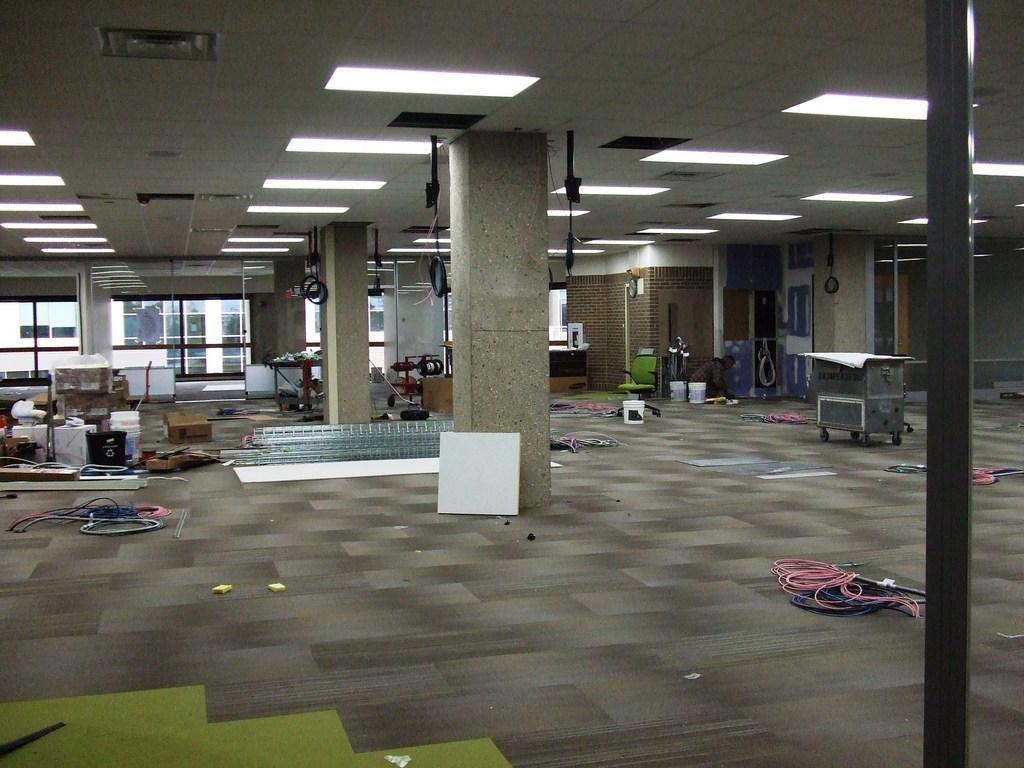Please provide a concise description of this image. This image is clicked inside the building. In the front, we can see the pillars. At the top, there is a roof along with the lights. At the bottom, there is a floor. And there are many things kept on the floor. On the right, we can see a trolley. 